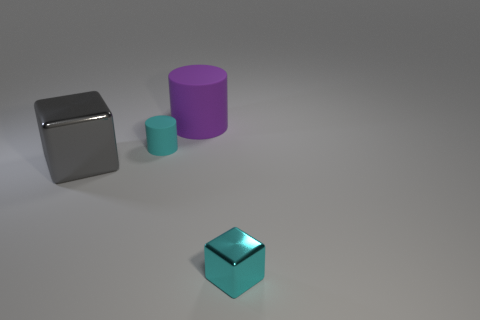There is a cyan object to the right of the cyan rubber cylinder; what shape is it?
Your answer should be compact. Cube. What is the color of the small cylinder?
Your answer should be very brief. Cyan. The other cube that is the same material as the small block is what color?
Ensure brevity in your answer.  Gray. What number of other objects are the same material as the purple object?
Make the answer very short. 1. There is a gray object; how many shiny things are right of it?
Offer a very short reply. 1. Is the thing behind the small cyan rubber object made of the same material as the thing that is right of the large purple matte cylinder?
Your answer should be very brief. No. Are there more small cyan rubber cylinders that are to the right of the large gray cube than gray metal objects that are on the right side of the tiny cyan metal cube?
Ensure brevity in your answer.  Yes. There is a thing that is the same color as the small cylinder; what is it made of?
Offer a very short reply. Metal. What material is the object that is in front of the tiny cyan rubber cylinder and on the left side of the cyan cube?
Your answer should be very brief. Metal. Do the large purple cylinder and the small cyan object behind the gray shiny thing have the same material?
Provide a succinct answer. Yes. 